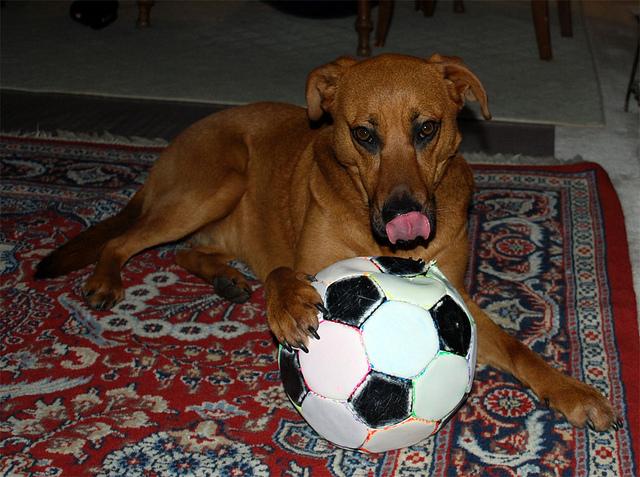What is visible on the edge of the rug?
Be succinct. Floor. What is in the dogs mouth?
Concise answer only. Tongue. Can the dog use this ball in the way it was intended by the maker?
Keep it brief. No. Has this dog been in the water?
Quick response, please. No. What sort of furniture is behind the dog?
Be succinct. Chair. 